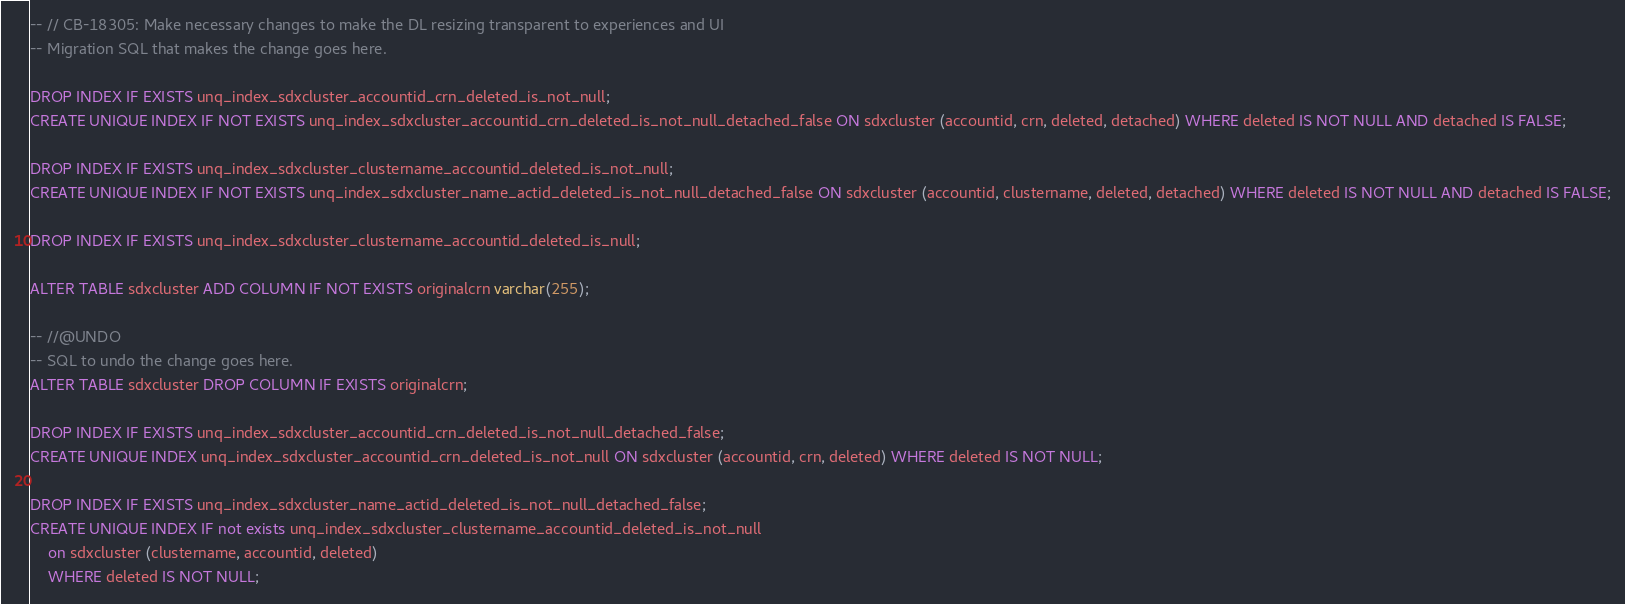<code> <loc_0><loc_0><loc_500><loc_500><_SQL_>-- // CB-18305: Make necessary changes to make the DL resizing transparent to experiences and UI
-- Migration SQL that makes the change goes here.

DROP INDEX IF EXISTS unq_index_sdxcluster_accountid_crn_deleted_is_not_null;
CREATE UNIQUE INDEX IF NOT EXISTS unq_index_sdxcluster_accountid_crn_deleted_is_not_null_detached_false ON sdxcluster (accountid, crn, deleted, detached) WHERE deleted IS NOT NULL AND detached IS FALSE;

DROP INDEX IF EXISTS unq_index_sdxcluster_clustername_accountid_deleted_is_not_null;
CREATE UNIQUE INDEX IF NOT EXISTS unq_index_sdxcluster_name_actid_deleted_is_not_null_detached_false ON sdxcluster (accountid, clustername, deleted, detached) WHERE deleted IS NOT NULL AND detached IS FALSE;

DROP INDEX IF EXISTS unq_index_sdxcluster_clustername_accountid_deleted_is_null;

ALTER TABLE sdxcluster ADD COLUMN IF NOT EXISTS originalcrn varchar(255);

-- //@UNDO
-- SQL to undo the change goes here.
ALTER TABLE sdxcluster DROP COLUMN IF EXISTS originalcrn;

DROP INDEX IF EXISTS unq_index_sdxcluster_accountid_crn_deleted_is_not_null_detached_false;
CREATE UNIQUE INDEX unq_index_sdxcluster_accountid_crn_deleted_is_not_null ON sdxcluster (accountid, crn, deleted) WHERE deleted IS NOT NULL;

DROP INDEX IF EXISTS unq_index_sdxcluster_name_actid_deleted_is_not_null_detached_false;
CREATE UNIQUE INDEX IF not exists unq_index_sdxcluster_clustername_accountid_deleted_is_not_null
	on sdxcluster (clustername, accountid, deleted)
	WHERE deleted IS NOT NULL;</code> 